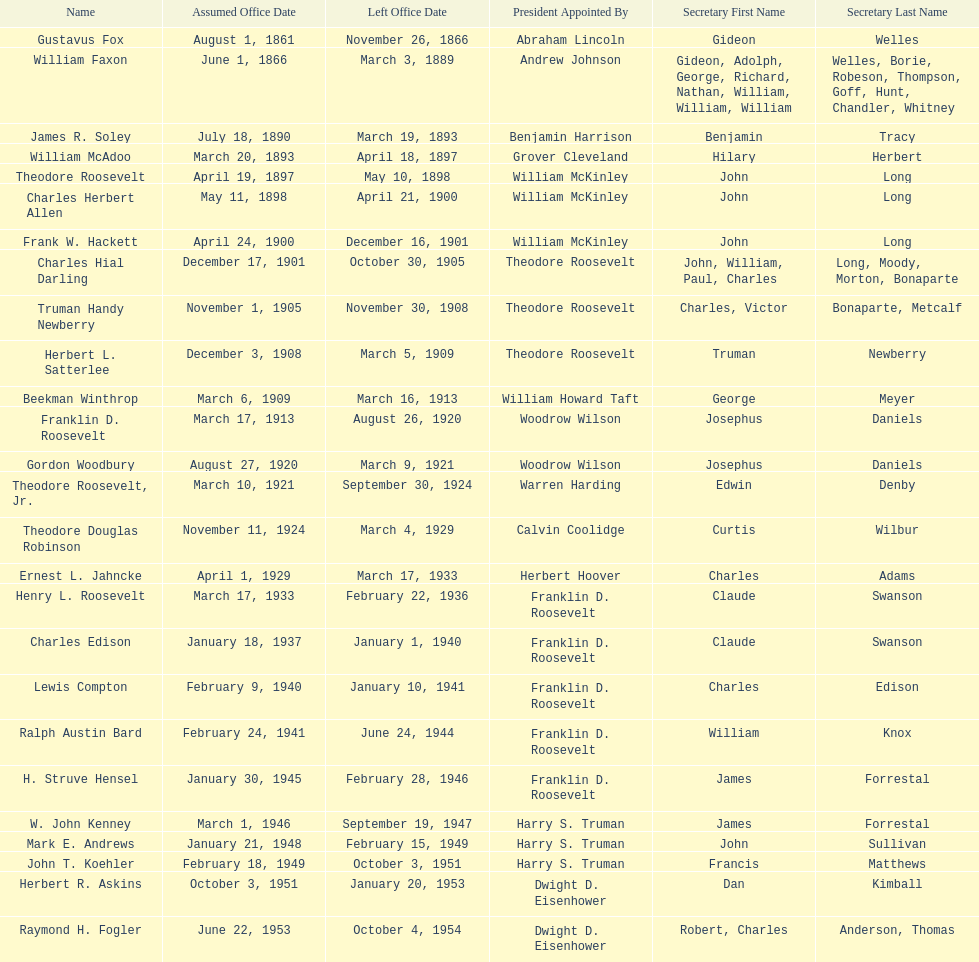When did raymond h. fogler leave the office of assistant secretary of the navy? October 4, 1954. 